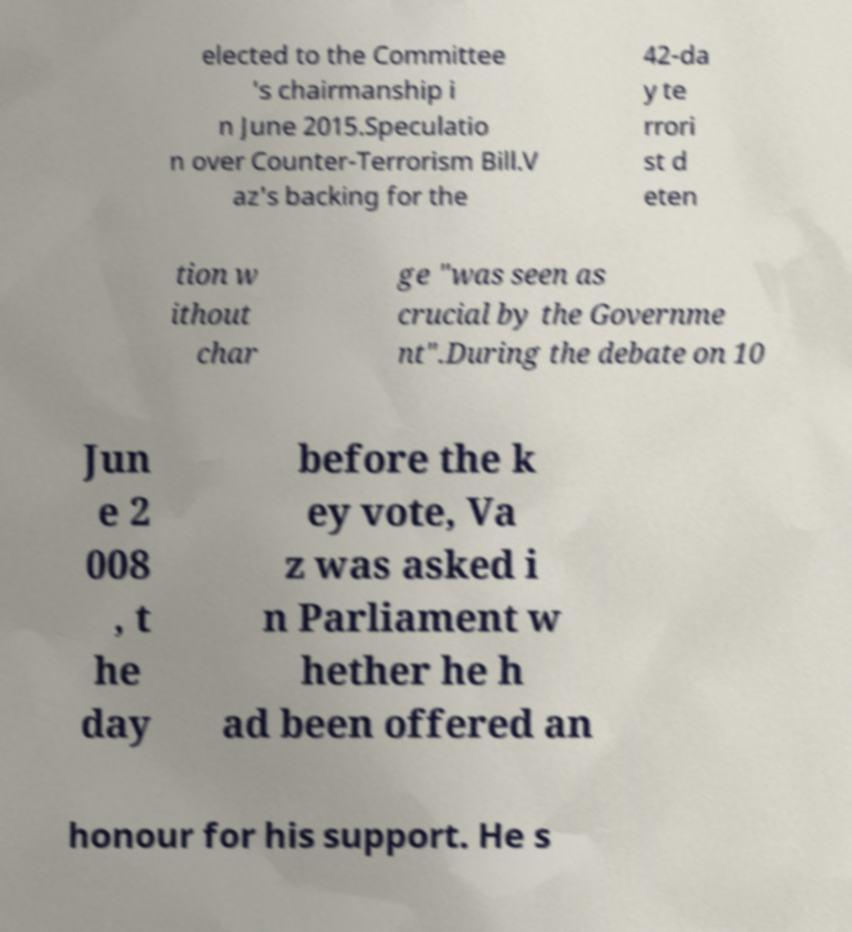I need the written content from this picture converted into text. Can you do that? elected to the Committee 's chairmanship i n June 2015.Speculatio n over Counter-Terrorism Bill.V az's backing for the 42-da y te rrori st d eten tion w ithout char ge "was seen as crucial by the Governme nt".During the debate on 10 Jun e 2 008 , t he day before the k ey vote, Va z was asked i n Parliament w hether he h ad been offered an honour for his support. He s 